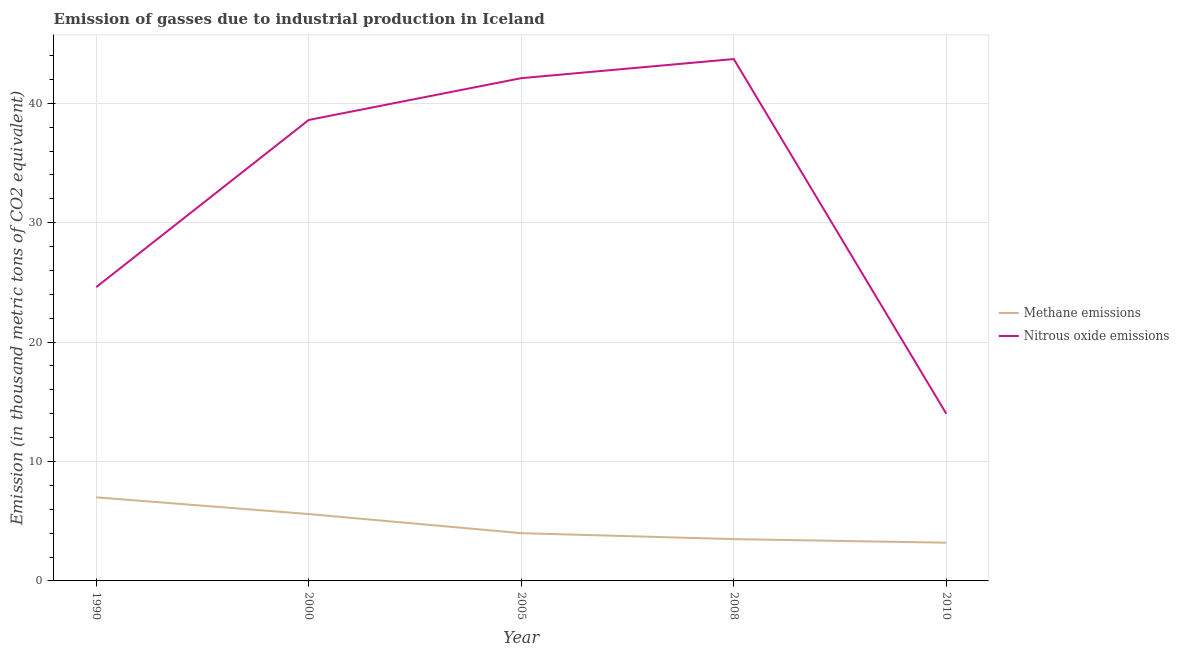Does the line corresponding to amount of nitrous oxide emissions intersect with the line corresponding to amount of methane emissions?
Your answer should be compact. No. Is the number of lines equal to the number of legend labels?
Your answer should be very brief. Yes. What is the amount of nitrous oxide emissions in 2005?
Your answer should be compact. 42.1. Across all years, what is the maximum amount of nitrous oxide emissions?
Provide a short and direct response. 43.7. Across all years, what is the minimum amount of nitrous oxide emissions?
Offer a very short reply. 14. In which year was the amount of nitrous oxide emissions minimum?
Offer a terse response. 2010. What is the total amount of methane emissions in the graph?
Provide a succinct answer. 23.3. What is the difference between the amount of nitrous oxide emissions in 2008 and that in 2010?
Ensure brevity in your answer.  29.7. What is the difference between the amount of nitrous oxide emissions in 2008 and the amount of methane emissions in 1990?
Your response must be concise. 36.7. What is the average amount of methane emissions per year?
Offer a terse response. 4.66. In the year 2008, what is the difference between the amount of methane emissions and amount of nitrous oxide emissions?
Offer a terse response. -40.2. What is the ratio of the amount of methane emissions in 1990 to that in 2005?
Keep it short and to the point. 1.75. Is the amount of methane emissions in 1990 less than that in 2008?
Ensure brevity in your answer.  No. What is the difference between the highest and the second highest amount of nitrous oxide emissions?
Your response must be concise. 1.6. What is the difference between the highest and the lowest amount of methane emissions?
Provide a short and direct response. 3.8. Does the amount of methane emissions monotonically increase over the years?
Offer a terse response. No. Is the amount of nitrous oxide emissions strictly less than the amount of methane emissions over the years?
Keep it short and to the point. No. How many lines are there?
Provide a succinct answer. 2. How many years are there in the graph?
Ensure brevity in your answer.  5. Where does the legend appear in the graph?
Your answer should be compact. Center right. How many legend labels are there?
Provide a succinct answer. 2. How are the legend labels stacked?
Keep it short and to the point. Vertical. What is the title of the graph?
Give a very brief answer. Emission of gasses due to industrial production in Iceland. Does "RDB nonconcessional" appear as one of the legend labels in the graph?
Provide a short and direct response. No. What is the label or title of the Y-axis?
Provide a succinct answer. Emission (in thousand metric tons of CO2 equivalent). What is the Emission (in thousand metric tons of CO2 equivalent) of Methane emissions in 1990?
Your answer should be very brief. 7. What is the Emission (in thousand metric tons of CO2 equivalent) of Nitrous oxide emissions in 1990?
Provide a short and direct response. 24.6. What is the Emission (in thousand metric tons of CO2 equivalent) of Nitrous oxide emissions in 2000?
Keep it short and to the point. 38.6. What is the Emission (in thousand metric tons of CO2 equivalent) in Methane emissions in 2005?
Ensure brevity in your answer.  4. What is the Emission (in thousand metric tons of CO2 equivalent) in Nitrous oxide emissions in 2005?
Your answer should be compact. 42.1. What is the Emission (in thousand metric tons of CO2 equivalent) in Nitrous oxide emissions in 2008?
Provide a short and direct response. 43.7. Across all years, what is the maximum Emission (in thousand metric tons of CO2 equivalent) of Methane emissions?
Ensure brevity in your answer.  7. Across all years, what is the maximum Emission (in thousand metric tons of CO2 equivalent) in Nitrous oxide emissions?
Make the answer very short. 43.7. Across all years, what is the minimum Emission (in thousand metric tons of CO2 equivalent) in Methane emissions?
Offer a very short reply. 3.2. Across all years, what is the minimum Emission (in thousand metric tons of CO2 equivalent) of Nitrous oxide emissions?
Make the answer very short. 14. What is the total Emission (in thousand metric tons of CO2 equivalent) in Methane emissions in the graph?
Give a very brief answer. 23.3. What is the total Emission (in thousand metric tons of CO2 equivalent) of Nitrous oxide emissions in the graph?
Ensure brevity in your answer.  163. What is the difference between the Emission (in thousand metric tons of CO2 equivalent) of Methane emissions in 1990 and that in 2005?
Provide a succinct answer. 3. What is the difference between the Emission (in thousand metric tons of CO2 equivalent) of Nitrous oxide emissions in 1990 and that in 2005?
Your answer should be compact. -17.5. What is the difference between the Emission (in thousand metric tons of CO2 equivalent) of Methane emissions in 1990 and that in 2008?
Provide a short and direct response. 3.5. What is the difference between the Emission (in thousand metric tons of CO2 equivalent) in Nitrous oxide emissions in 1990 and that in 2008?
Make the answer very short. -19.1. What is the difference between the Emission (in thousand metric tons of CO2 equivalent) in Methane emissions in 1990 and that in 2010?
Make the answer very short. 3.8. What is the difference between the Emission (in thousand metric tons of CO2 equivalent) in Nitrous oxide emissions in 2000 and that in 2005?
Your answer should be compact. -3.5. What is the difference between the Emission (in thousand metric tons of CO2 equivalent) in Methane emissions in 2000 and that in 2010?
Ensure brevity in your answer.  2.4. What is the difference between the Emission (in thousand metric tons of CO2 equivalent) in Nitrous oxide emissions in 2000 and that in 2010?
Your answer should be compact. 24.6. What is the difference between the Emission (in thousand metric tons of CO2 equivalent) in Methane emissions in 2005 and that in 2008?
Offer a terse response. 0.5. What is the difference between the Emission (in thousand metric tons of CO2 equivalent) in Nitrous oxide emissions in 2005 and that in 2008?
Provide a short and direct response. -1.6. What is the difference between the Emission (in thousand metric tons of CO2 equivalent) of Nitrous oxide emissions in 2005 and that in 2010?
Provide a short and direct response. 28.1. What is the difference between the Emission (in thousand metric tons of CO2 equivalent) of Methane emissions in 2008 and that in 2010?
Offer a very short reply. 0.3. What is the difference between the Emission (in thousand metric tons of CO2 equivalent) in Nitrous oxide emissions in 2008 and that in 2010?
Provide a succinct answer. 29.7. What is the difference between the Emission (in thousand metric tons of CO2 equivalent) in Methane emissions in 1990 and the Emission (in thousand metric tons of CO2 equivalent) in Nitrous oxide emissions in 2000?
Your answer should be very brief. -31.6. What is the difference between the Emission (in thousand metric tons of CO2 equivalent) of Methane emissions in 1990 and the Emission (in thousand metric tons of CO2 equivalent) of Nitrous oxide emissions in 2005?
Keep it short and to the point. -35.1. What is the difference between the Emission (in thousand metric tons of CO2 equivalent) in Methane emissions in 1990 and the Emission (in thousand metric tons of CO2 equivalent) in Nitrous oxide emissions in 2008?
Your response must be concise. -36.7. What is the difference between the Emission (in thousand metric tons of CO2 equivalent) of Methane emissions in 2000 and the Emission (in thousand metric tons of CO2 equivalent) of Nitrous oxide emissions in 2005?
Your answer should be very brief. -36.5. What is the difference between the Emission (in thousand metric tons of CO2 equivalent) of Methane emissions in 2000 and the Emission (in thousand metric tons of CO2 equivalent) of Nitrous oxide emissions in 2008?
Your answer should be very brief. -38.1. What is the difference between the Emission (in thousand metric tons of CO2 equivalent) in Methane emissions in 2005 and the Emission (in thousand metric tons of CO2 equivalent) in Nitrous oxide emissions in 2008?
Offer a terse response. -39.7. What is the difference between the Emission (in thousand metric tons of CO2 equivalent) of Methane emissions in 2005 and the Emission (in thousand metric tons of CO2 equivalent) of Nitrous oxide emissions in 2010?
Ensure brevity in your answer.  -10. What is the difference between the Emission (in thousand metric tons of CO2 equivalent) of Methane emissions in 2008 and the Emission (in thousand metric tons of CO2 equivalent) of Nitrous oxide emissions in 2010?
Ensure brevity in your answer.  -10.5. What is the average Emission (in thousand metric tons of CO2 equivalent) in Methane emissions per year?
Give a very brief answer. 4.66. What is the average Emission (in thousand metric tons of CO2 equivalent) in Nitrous oxide emissions per year?
Your response must be concise. 32.6. In the year 1990, what is the difference between the Emission (in thousand metric tons of CO2 equivalent) in Methane emissions and Emission (in thousand metric tons of CO2 equivalent) in Nitrous oxide emissions?
Give a very brief answer. -17.6. In the year 2000, what is the difference between the Emission (in thousand metric tons of CO2 equivalent) of Methane emissions and Emission (in thousand metric tons of CO2 equivalent) of Nitrous oxide emissions?
Keep it short and to the point. -33. In the year 2005, what is the difference between the Emission (in thousand metric tons of CO2 equivalent) of Methane emissions and Emission (in thousand metric tons of CO2 equivalent) of Nitrous oxide emissions?
Your answer should be very brief. -38.1. In the year 2008, what is the difference between the Emission (in thousand metric tons of CO2 equivalent) in Methane emissions and Emission (in thousand metric tons of CO2 equivalent) in Nitrous oxide emissions?
Give a very brief answer. -40.2. In the year 2010, what is the difference between the Emission (in thousand metric tons of CO2 equivalent) in Methane emissions and Emission (in thousand metric tons of CO2 equivalent) in Nitrous oxide emissions?
Offer a very short reply. -10.8. What is the ratio of the Emission (in thousand metric tons of CO2 equivalent) in Nitrous oxide emissions in 1990 to that in 2000?
Keep it short and to the point. 0.64. What is the ratio of the Emission (in thousand metric tons of CO2 equivalent) of Methane emissions in 1990 to that in 2005?
Provide a short and direct response. 1.75. What is the ratio of the Emission (in thousand metric tons of CO2 equivalent) in Nitrous oxide emissions in 1990 to that in 2005?
Give a very brief answer. 0.58. What is the ratio of the Emission (in thousand metric tons of CO2 equivalent) in Nitrous oxide emissions in 1990 to that in 2008?
Your answer should be very brief. 0.56. What is the ratio of the Emission (in thousand metric tons of CO2 equivalent) in Methane emissions in 1990 to that in 2010?
Give a very brief answer. 2.19. What is the ratio of the Emission (in thousand metric tons of CO2 equivalent) in Nitrous oxide emissions in 1990 to that in 2010?
Keep it short and to the point. 1.76. What is the ratio of the Emission (in thousand metric tons of CO2 equivalent) in Nitrous oxide emissions in 2000 to that in 2005?
Your answer should be very brief. 0.92. What is the ratio of the Emission (in thousand metric tons of CO2 equivalent) of Nitrous oxide emissions in 2000 to that in 2008?
Offer a very short reply. 0.88. What is the ratio of the Emission (in thousand metric tons of CO2 equivalent) of Methane emissions in 2000 to that in 2010?
Give a very brief answer. 1.75. What is the ratio of the Emission (in thousand metric tons of CO2 equivalent) in Nitrous oxide emissions in 2000 to that in 2010?
Provide a succinct answer. 2.76. What is the ratio of the Emission (in thousand metric tons of CO2 equivalent) of Methane emissions in 2005 to that in 2008?
Offer a terse response. 1.14. What is the ratio of the Emission (in thousand metric tons of CO2 equivalent) in Nitrous oxide emissions in 2005 to that in 2008?
Your answer should be very brief. 0.96. What is the ratio of the Emission (in thousand metric tons of CO2 equivalent) in Methane emissions in 2005 to that in 2010?
Offer a terse response. 1.25. What is the ratio of the Emission (in thousand metric tons of CO2 equivalent) in Nitrous oxide emissions in 2005 to that in 2010?
Provide a short and direct response. 3.01. What is the ratio of the Emission (in thousand metric tons of CO2 equivalent) of Methane emissions in 2008 to that in 2010?
Give a very brief answer. 1.09. What is the ratio of the Emission (in thousand metric tons of CO2 equivalent) of Nitrous oxide emissions in 2008 to that in 2010?
Offer a terse response. 3.12. What is the difference between the highest and the lowest Emission (in thousand metric tons of CO2 equivalent) in Nitrous oxide emissions?
Give a very brief answer. 29.7. 